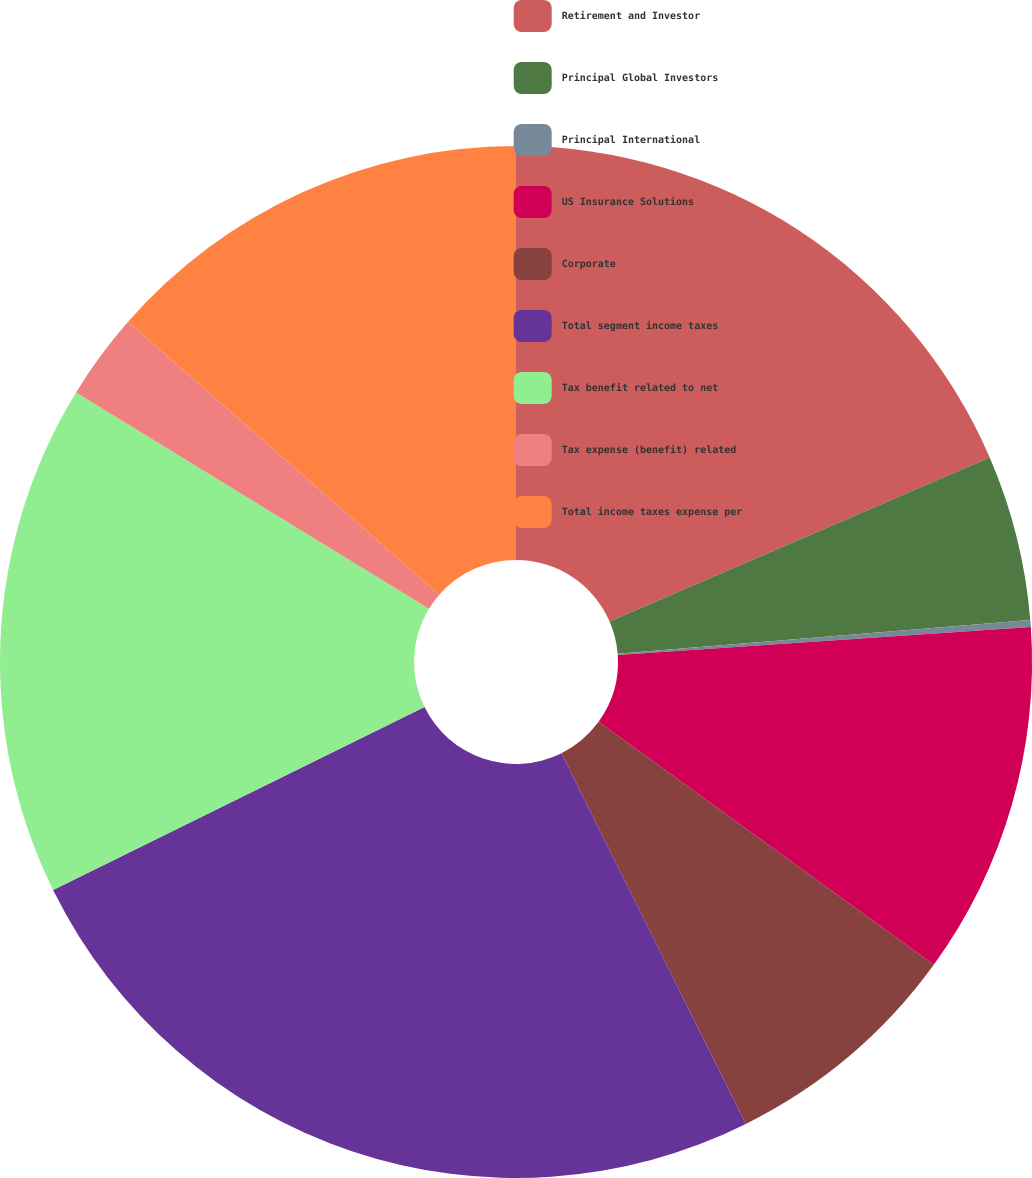Convert chart. <chart><loc_0><loc_0><loc_500><loc_500><pie_chart><fcel>Retirement and Investor<fcel>Principal Global Investors<fcel>Principal International<fcel>US Insurance Solutions<fcel>Corporate<fcel>Total segment income taxes<fcel>Tax benefit related to net<fcel>Tax expense (benefit) related<fcel>Total income taxes expense per<nl><fcel>18.51%<fcel>5.19%<fcel>0.22%<fcel>11.06%<fcel>7.67%<fcel>25.06%<fcel>16.03%<fcel>2.71%<fcel>13.54%<nl></chart> 